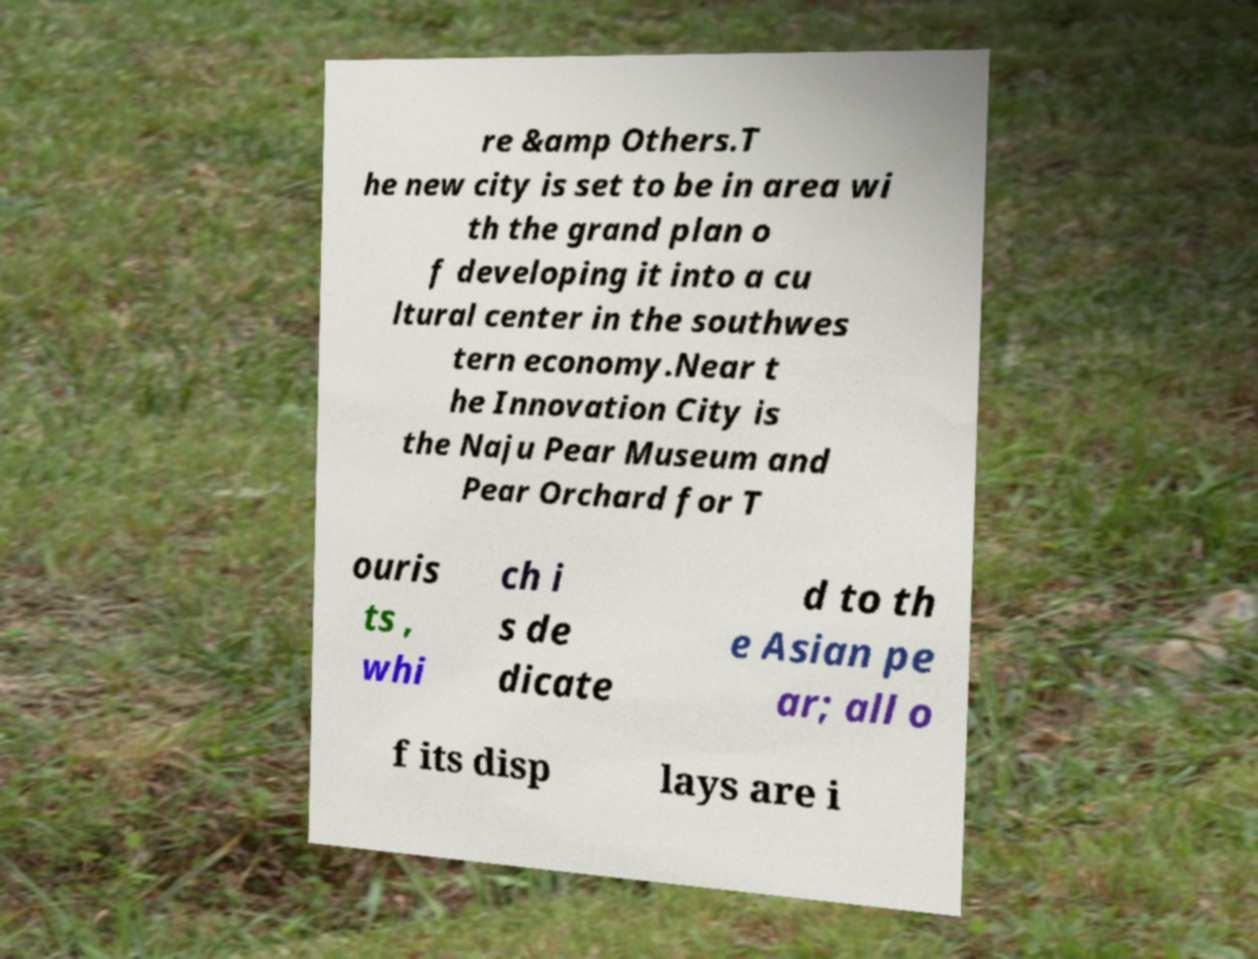Can you accurately transcribe the text from the provided image for me? re &amp Others.T he new city is set to be in area wi th the grand plan o f developing it into a cu ltural center in the southwes tern economy.Near t he Innovation City is the Naju Pear Museum and Pear Orchard for T ouris ts , whi ch i s de dicate d to th e Asian pe ar; all o f its disp lays are i 